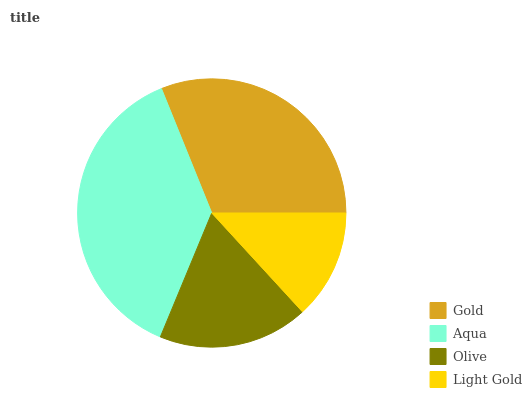Is Light Gold the minimum?
Answer yes or no. Yes. Is Aqua the maximum?
Answer yes or no. Yes. Is Olive the minimum?
Answer yes or no. No. Is Olive the maximum?
Answer yes or no. No. Is Aqua greater than Olive?
Answer yes or no. Yes. Is Olive less than Aqua?
Answer yes or no. Yes. Is Olive greater than Aqua?
Answer yes or no. No. Is Aqua less than Olive?
Answer yes or no. No. Is Gold the high median?
Answer yes or no. Yes. Is Olive the low median?
Answer yes or no. Yes. Is Aqua the high median?
Answer yes or no. No. Is Light Gold the low median?
Answer yes or no. No. 